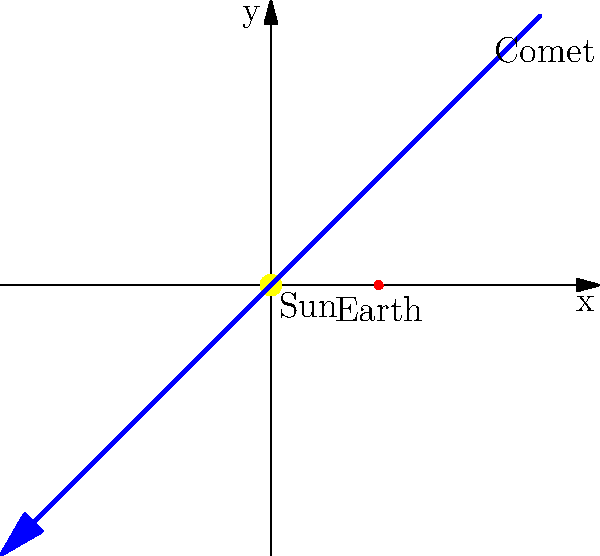In ancient religious texts, comets were often interpreted as divine messages or omens. How does this interpretation align with our modern understanding of comet trajectories, as shown in the diagram, and what theological implications might this have for our interpretation of celestial phenomena? To answer this question, we need to consider several aspects:

1. Ancient interpretations: In many religious texts, including some Jewish sources, comets were seen as divine signs or portents of significant events.

2. Modern understanding: The diagram shows a scientific representation of a comet's trajectory around the Sun, following a predictable path due to gravitational forces.

3. Contrast: The ancient view sees comets as supernatural occurrences, while modern astronomy explains them as natural phenomena.

4. Theological implications:
   a) Reinterpretation: We may need to reinterpret ancient texts in light of scientific knowledge.
   b) Divine design: Some might argue that the predictable nature of comets reflects divine order in the universe.
   c) Metaphorical understanding: Ancient interpretations could be seen as metaphorical rather than literal.
   d) Limits of human knowledge: This contrast reminds us of the evolving nature of human understanding.

5. Reconciliation: As a Rabbi and academic, one might propose that both scientific and religious perspectives can coexist, with science explaining the "how" and religion addressing the "why" of cosmic phenomena.

6. Ethical considerations: This understanding can lead to discussions about the responsibility of religious leaders to integrate scientific knowledge into their teachings.

7. Historical context: It's important to consider the historical and cultural contexts in which these ancient interpretations were formed.

The alignment of ancient interpretations with modern understanding thus presents both challenges and opportunities for theological reflection and interpretation.
Answer: Ancient interpretations of comets as divine signs contrast with modern scientific understanding, necessitating a reexamination of religious texts and the relationship between science and faith. 